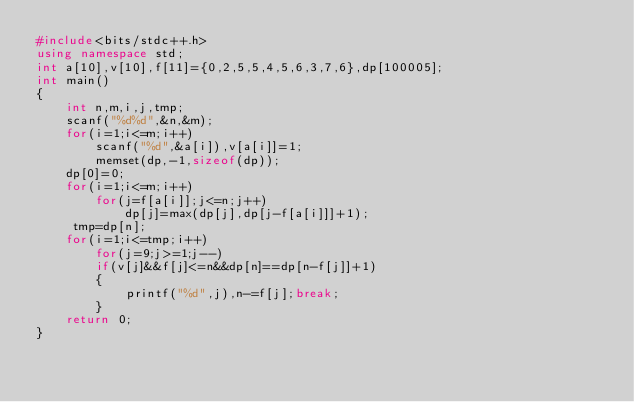Convert code to text. <code><loc_0><loc_0><loc_500><loc_500><_C++_>#include<bits/stdc++.h>
using namespace std;
int a[10],v[10],f[11]={0,2,5,5,4,5,6,3,7,6},dp[100005];
int main()
{
    int n,m,i,j,tmp;
    scanf("%d%d",&n,&m);
    for(i=1;i<=m;i++)
        scanf("%d",&a[i]),v[a[i]]=1;
        memset(dp,-1,sizeof(dp));
    dp[0]=0;
    for(i=1;i<=m;i++)
        for(j=f[a[i]];j<=n;j++)
            dp[j]=max(dp[j],dp[j-f[a[i]]]+1);
     tmp=dp[n];
    for(i=1;i<=tmp;i++)
        for(j=9;j>=1;j--)
        if(v[j]&&f[j]<=n&&dp[n]==dp[n-f[j]]+1)
        {
            printf("%d",j),n-=f[j];break;
        }
    return 0;
}
</code> 